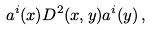Convert formula to latex. <formula><loc_0><loc_0><loc_500><loc_500>a ^ { i } ( x ) D ^ { 2 } ( x , y ) a ^ { i } ( y ) \, ,</formula> 